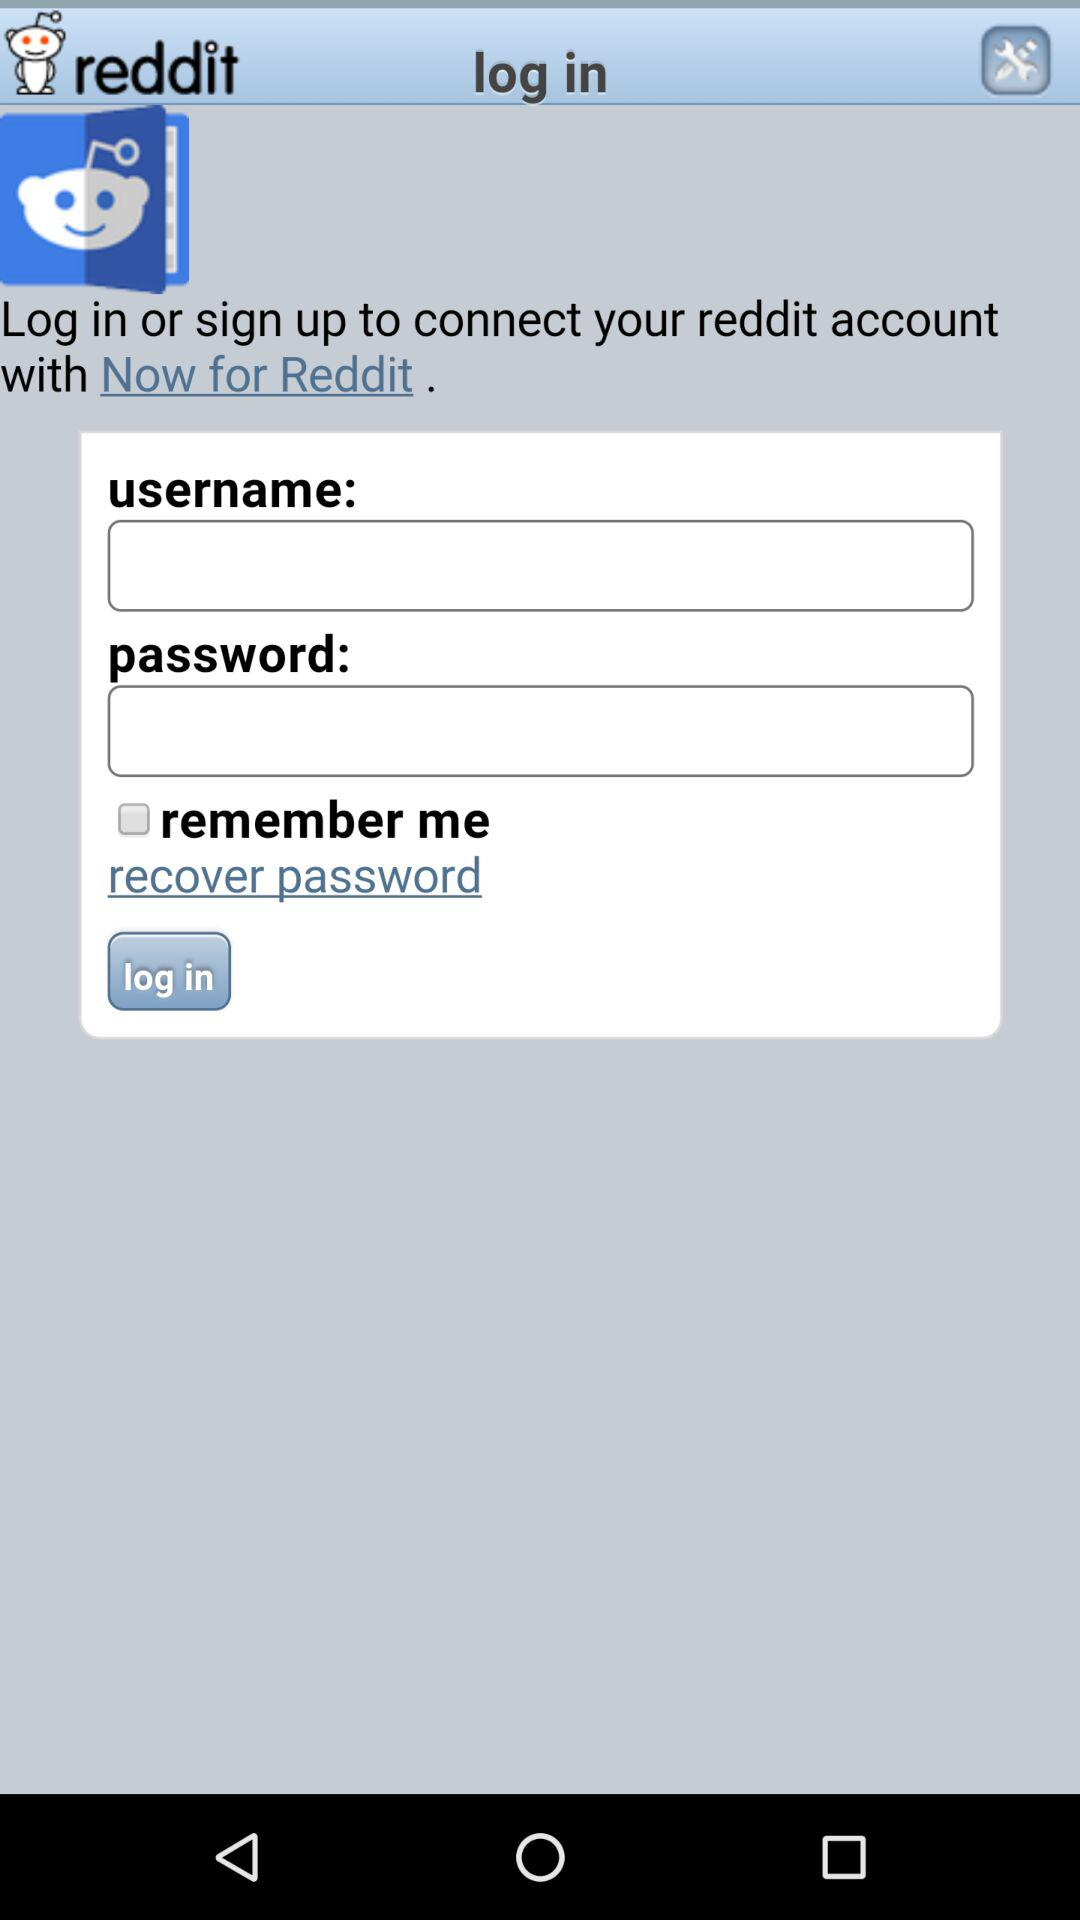How can we log in?
When the provided information is insufficient, respond with <no answer>. <no answer> 